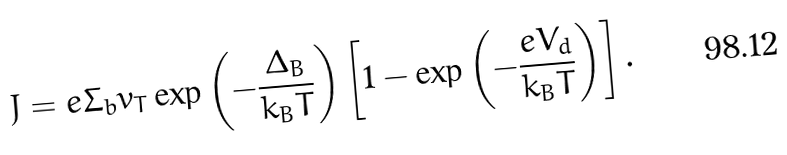Convert formula to latex. <formula><loc_0><loc_0><loc_500><loc_500>J = e \Sigma _ { b } v _ { T } \exp \left ( - \frac { \Delta _ { B } } { k _ { B } T } \right ) \left [ 1 - \exp \left ( - \frac { e V _ { d } } { k _ { B } T } \right ) \right ] .</formula> 